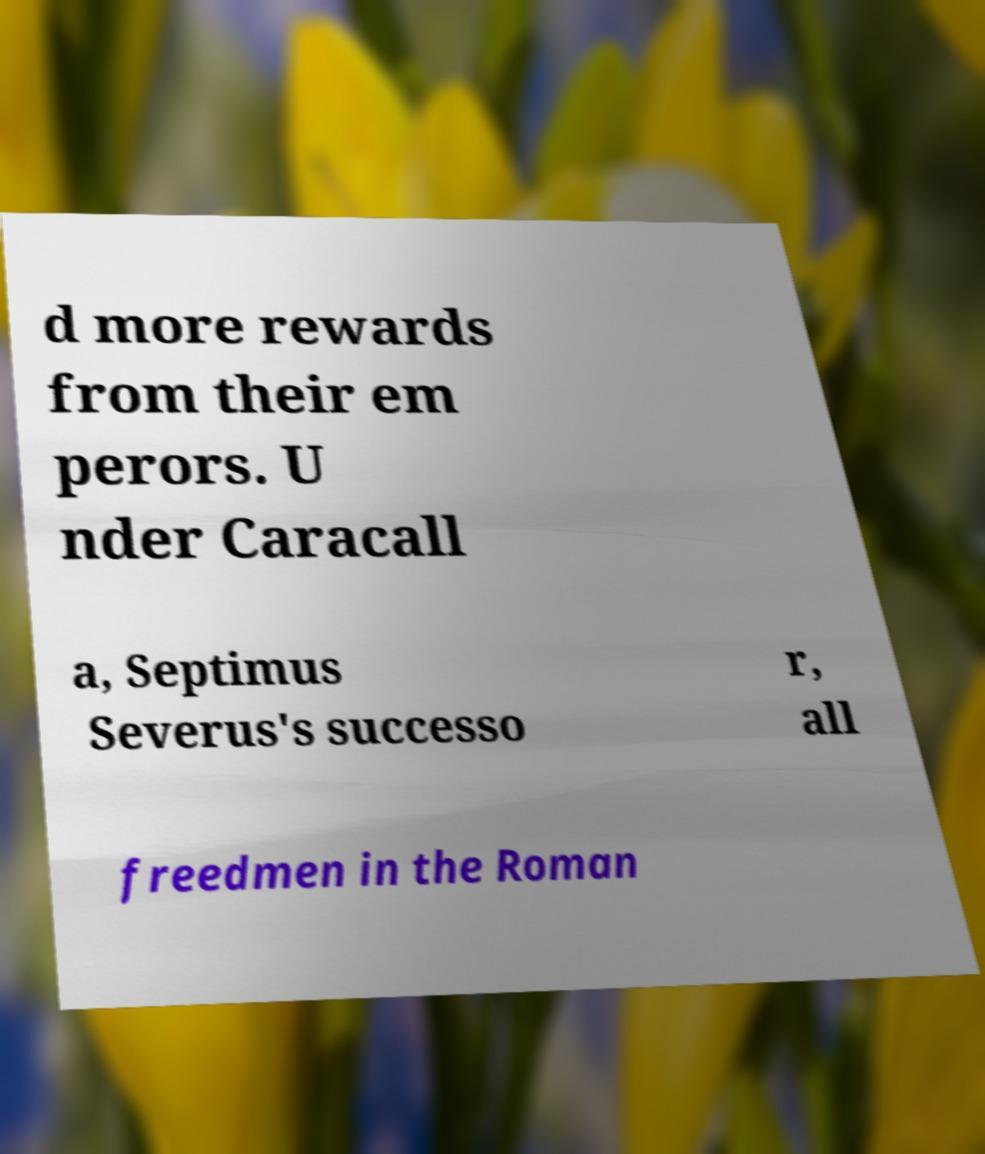Please read and relay the text visible in this image. What does it say? d more rewards from their em perors. U nder Caracall a, Septimus Severus's successo r, all freedmen in the Roman 